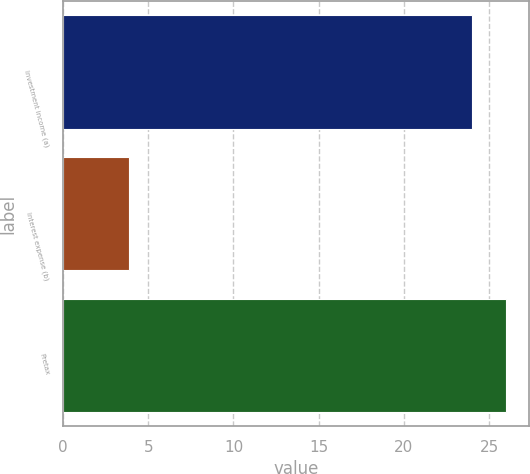Convert chart to OTSL. <chart><loc_0><loc_0><loc_500><loc_500><bar_chart><fcel>Investment income (a)<fcel>Interest expense (b)<fcel>Pretax<nl><fcel>24<fcel>3.89<fcel>26.01<nl></chart> 